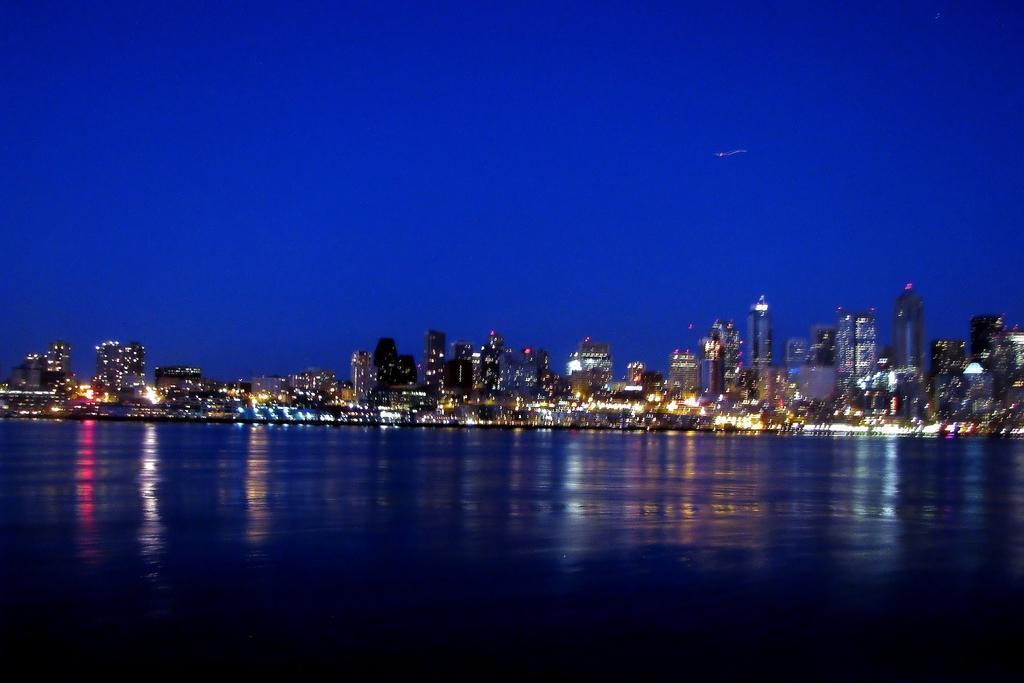Describe this image in one or two sentences. There are buildings, this is water and a sky. 